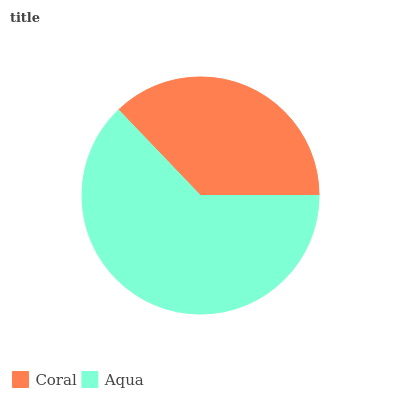Is Coral the minimum?
Answer yes or no. Yes. Is Aqua the maximum?
Answer yes or no. Yes. Is Aqua the minimum?
Answer yes or no. No. Is Aqua greater than Coral?
Answer yes or no. Yes. Is Coral less than Aqua?
Answer yes or no. Yes. Is Coral greater than Aqua?
Answer yes or no. No. Is Aqua less than Coral?
Answer yes or no. No. Is Aqua the high median?
Answer yes or no. Yes. Is Coral the low median?
Answer yes or no. Yes. Is Coral the high median?
Answer yes or no. No. Is Aqua the low median?
Answer yes or no. No. 